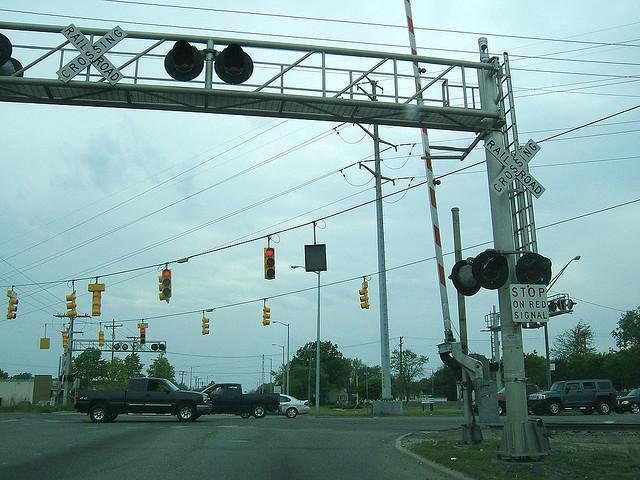How many trucks are there?
Give a very brief answer. 2. How many elephants have 2 people riding them?
Give a very brief answer. 0. 